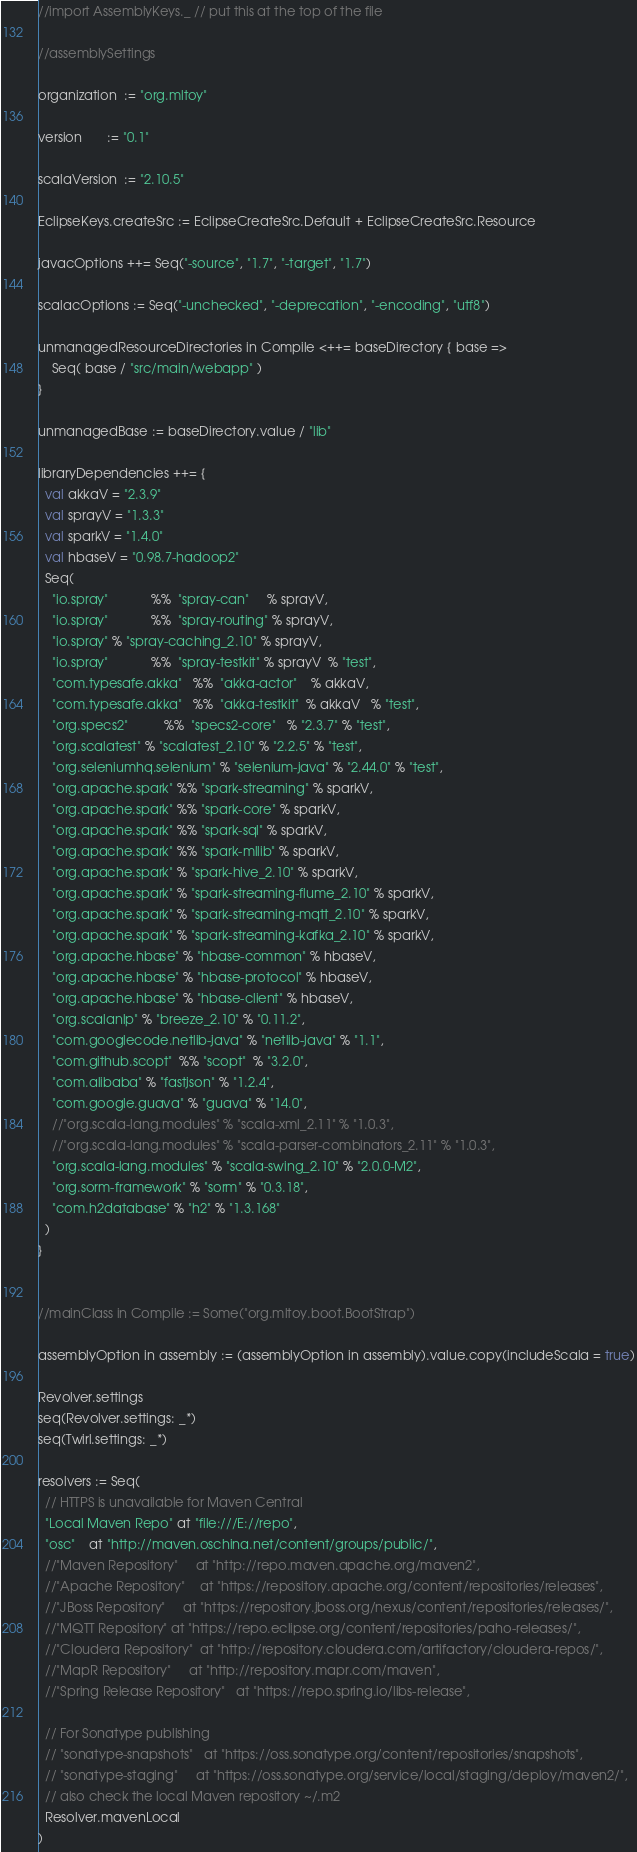<code> <loc_0><loc_0><loc_500><loc_500><_Scala_>//import AssemblyKeys._ // put this at the top of the file

//assemblySettings

organization  := "org.mltoy"

version       := "0.1"

scalaVersion  := "2.10.5"

EclipseKeys.createSrc := EclipseCreateSrc.Default + EclipseCreateSrc.Resource
 
javacOptions ++= Seq("-source", "1.7", "-target", "1.7")

scalacOptions := Seq("-unchecked", "-deprecation", "-encoding", "utf8")

unmanagedResourceDirectories in Compile <++= baseDirectory { base =>
    Seq( base / "src/main/webapp" )
}

unmanagedBase := baseDirectory.value / "lib"

libraryDependencies ++= {
  val akkaV = "2.3.9"
  val sprayV = "1.3.3"
  val sparkV = "1.4.0"
  val hbaseV = "0.98.7-hadoop2"
  Seq(
    "io.spray"            %%  "spray-can"     % sprayV,
    "io.spray"            %%  "spray-routing" % sprayV,
    "io.spray" % "spray-caching_2.10" % sprayV,
    "io.spray"            %%  "spray-testkit" % sprayV  % "test",
    "com.typesafe.akka"   %%  "akka-actor"    % akkaV,
    "com.typesafe.akka"   %%  "akka-testkit"  % akkaV   % "test",
    "org.specs2"          %%  "specs2-core"   % "2.3.7" % "test",
    "org.scalatest" % "scalatest_2.10" % "2.2.5" % "test",
    "org.seleniumhq.selenium" % "selenium-java" % "2.44.0" % "test",
    "org.apache.spark" %% "spark-streaming" % sparkV,
    "org.apache.spark" %% "spark-core" % sparkV,
    "org.apache.spark" %% "spark-sql" % sparkV,
    "org.apache.spark" %% "spark-mllib" % sparkV,
    "org.apache.spark" % "spark-hive_2.10" % sparkV,
    "org.apache.spark" % "spark-streaming-flume_2.10" % sparkV,
    "org.apache.spark" % "spark-streaming-mqtt_2.10" % sparkV,
    "org.apache.spark" % "spark-streaming-kafka_2.10" % sparkV,
    "org.apache.hbase" % "hbase-common" % hbaseV,
    "org.apache.hbase" % "hbase-protocol" % hbaseV,
    "org.apache.hbase" % "hbase-client" % hbaseV,
    "org.scalanlp" % "breeze_2.10" % "0.11.2",
    "com.googlecode.netlib-java" % "netlib-java" % "1.1",
    "com.github.scopt"  %% "scopt"  % "3.2.0",
    "com.alibaba" % "fastjson" % "1.2.4",
    "com.google.guava" % "guava" % "14.0",
    //"org.scala-lang.modules" % "scala-xml_2.11" % "1.0.3",
    //"org.scala-lang.modules" % "scala-parser-combinators_2.11" % "1.0.3",
    "org.scala-lang.modules" % "scala-swing_2.10" % "2.0.0-M2",
    "org.sorm-framework" % "sorm" % "0.3.18",
    "com.h2database" % "h2" % "1.3.168"
  )
}


//mainClass in Compile := Some("org.mltoy.boot.BootStrap")
 
assemblyOption in assembly := (assemblyOption in assembly).value.copy(includeScala = true)

Revolver.settings
seq(Revolver.settings: _*)
seq(Twirl.settings: _*)

resolvers := Seq(
  // HTTPS is unavailable for Maven Central
  "Local Maven Repo" at "file:///E://repo",
  "osc"	at "http://maven.oschina.net/content/groups/public/",
  //"Maven Repository"     at "http://repo.maven.apache.org/maven2",
  //"Apache Repository"    at "https://repository.apache.org/content/repositories/releases",
  //"JBoss Repository"     at "https://repository.jboss.org/nexus/content/repositories/releases/",
  //"MQTT Repository"	at "https://repo.eclipse.org/content/repositories/paho-releases/",
  //"Cloudera Repository"  at "http://repository.cloudera.com/artifactory/cloudera-repos/",
  //"MapR Repository"		at "http://repository.mapr.com/maven",
  //"Spring Release Repository"	at "https://repo.spring.io/libs-release",

  // For Sonatype publishing
  // "sonatype-snapshots"   at "https://oss.sonatype.org/content/repositories/snapshots",
  // "sonatype-staging"     at "https://oss.sonatype.org/service/local/staging/deploy/maven2/",
  // also check the local Maven repository ~/.m2
  Resolver.mavenLocal
)
</code> 